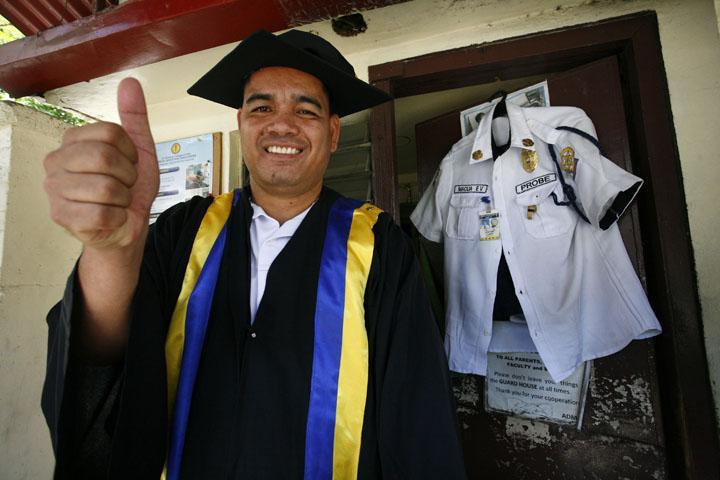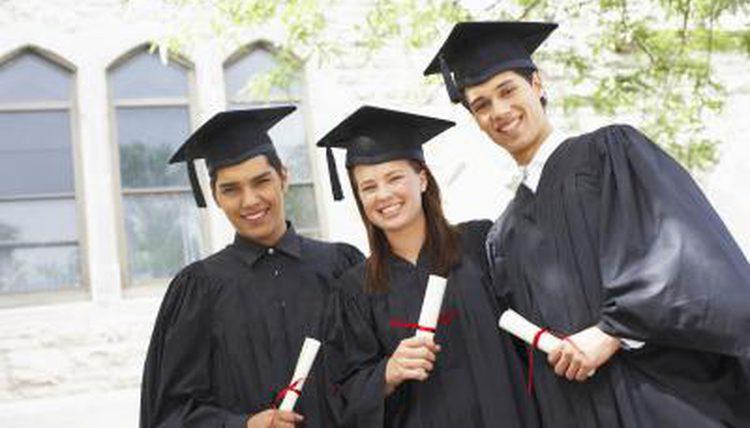The first image is the image on the left, the second image is the image on the right. Assess this claim about the two images: "The diplomas the people are holding have red ribbons around them.". Correct or not? Answer yes or no. Yes. 